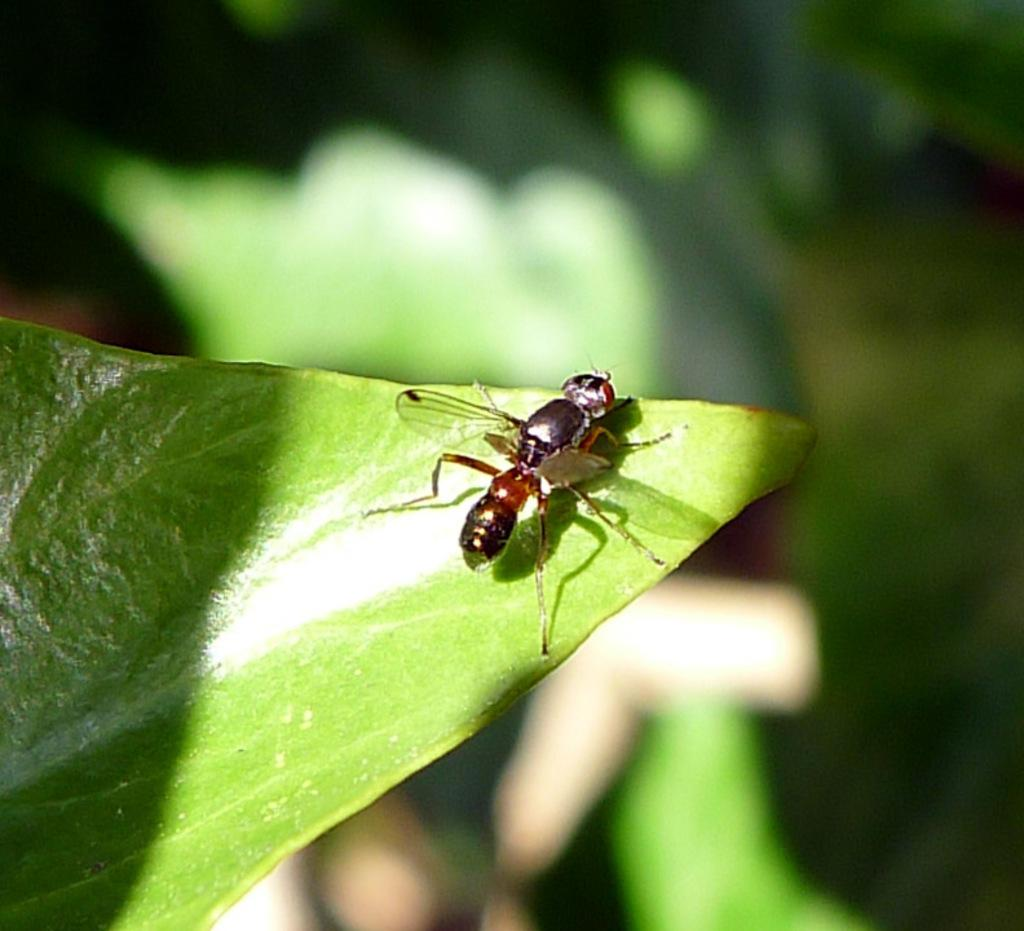What is present on the leaf in the image? There is an insect on a leaf in the image. Can you describe the background of the image? The background of the image is blurred. What type of fruit is hanging from the leaf in the image? There is no fruit present on the leaf in the image; it only features an insect. 